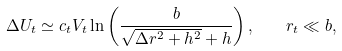Convert formula to latex. <formula><loc_0><loc_0><loc_500><loc_500>\Delta U _ { t } \simeq c _ { t } V _ { t } \ln \left ( \frac { b } { \sqrt { \Delta r ^ { 2 } + h ^ { 2 } } + h } \right ) , \quad r _ { t } \ll b ,</formula> 